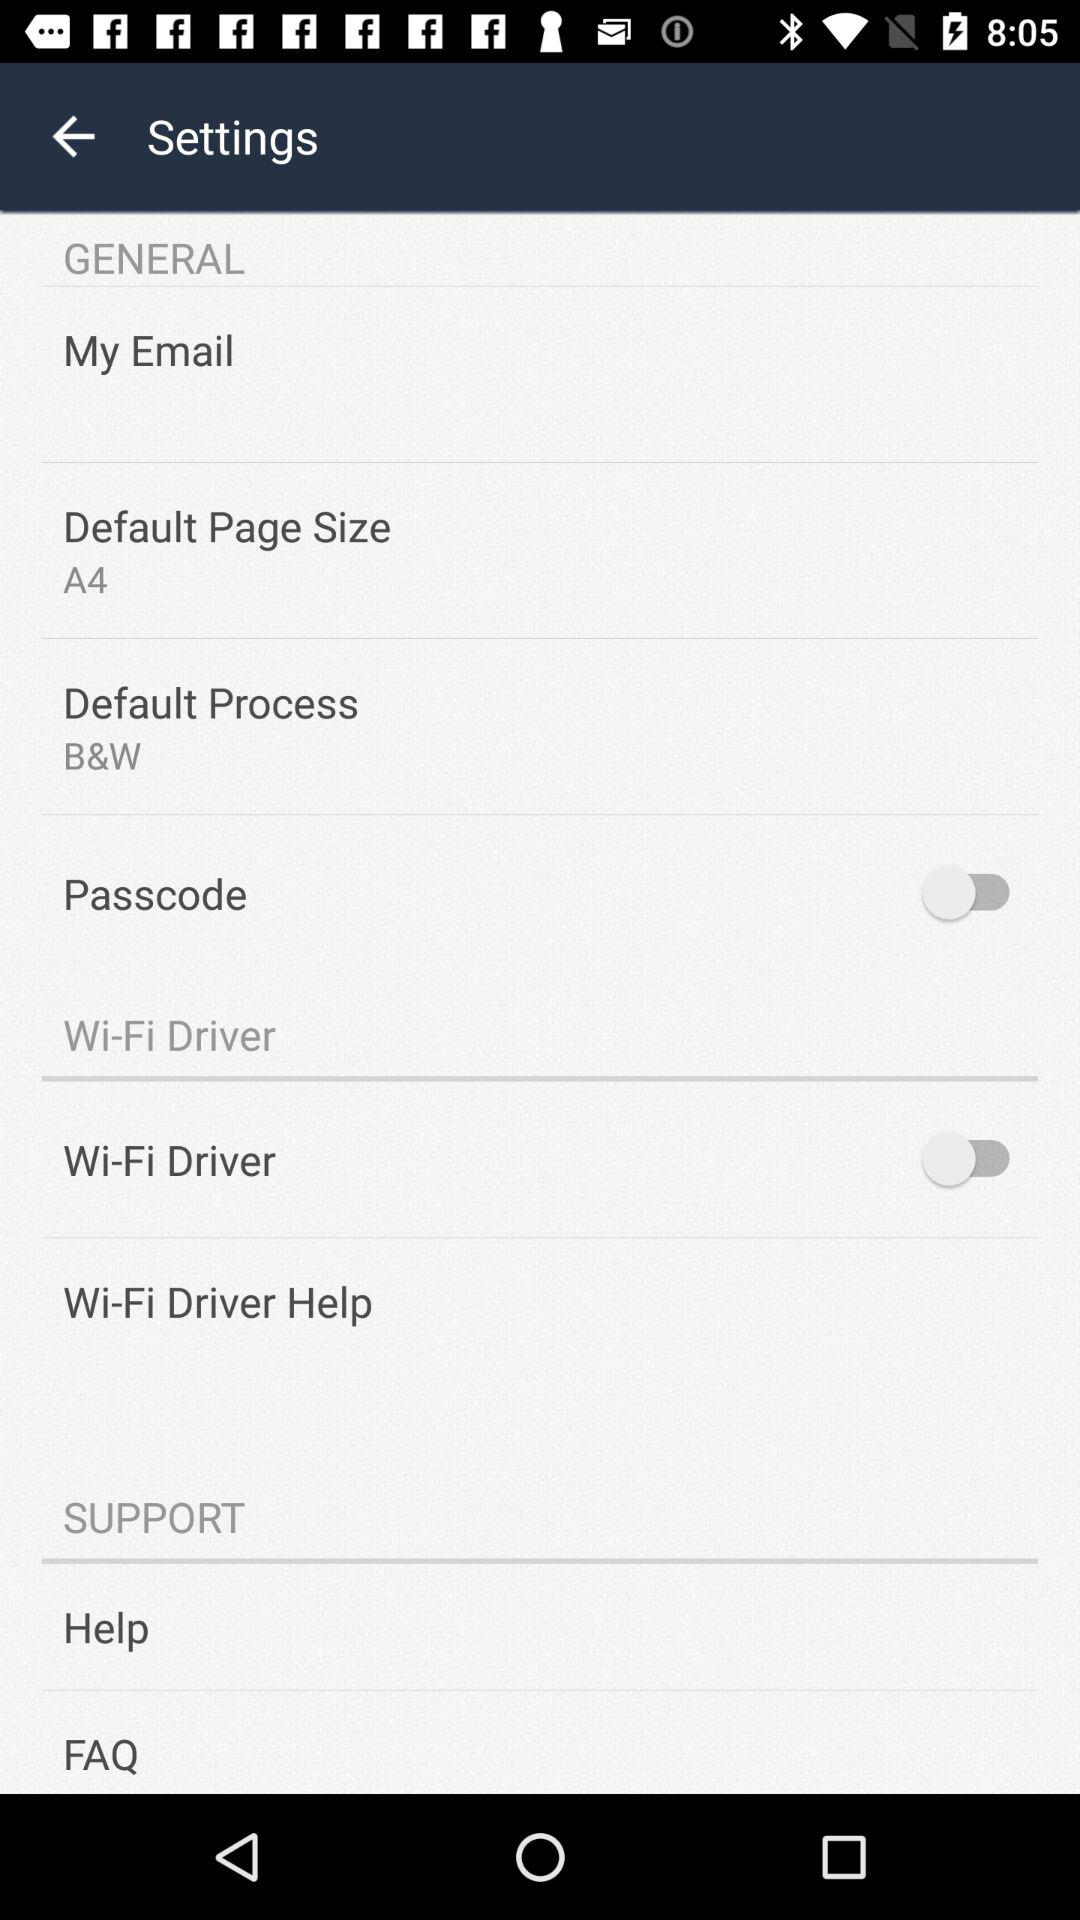What is the current status of "Wi-Fi Driver"? The current status is "off". 